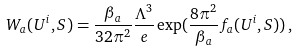Convert formula to latex. <formula><loc_0><loc_0><loc_500><loc_500>W _ { a } ( U ^ { i } , S ) = \frac { \beta _ { a } } { 3 2 \pi ^ { 2 } } \frac { \Lambda ^ { 3 } } { e } \exp ( \frac { 8 \pi ^ { 2 } } { \beta _ { a } } f _ { a } ( U ^ { i } , S ) ) \, ,</formula> 